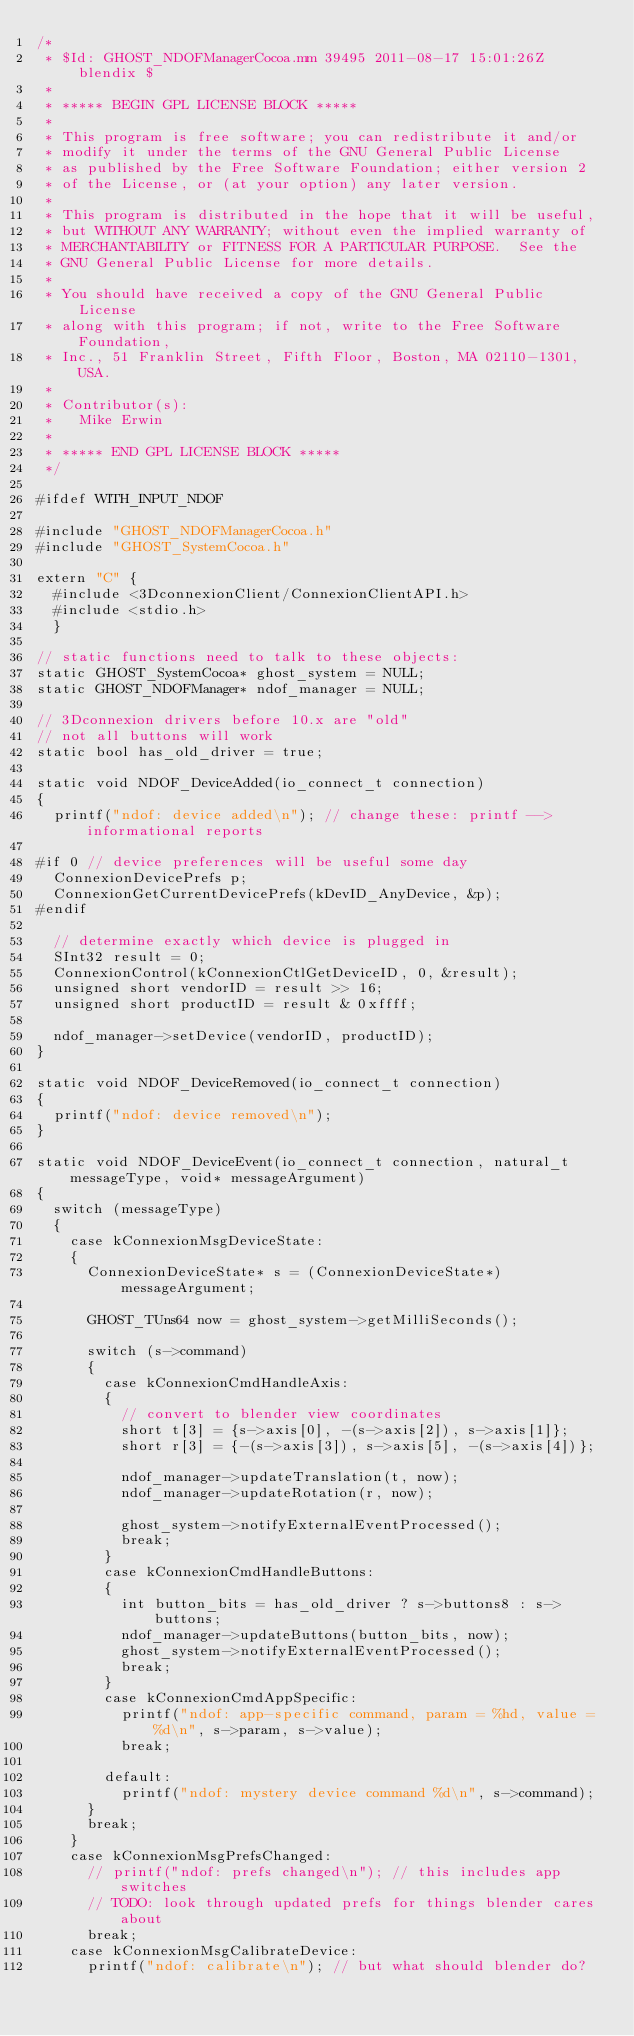<code> <loc_0><loc_0><loc_500><loc_500><_ObjectiveC_>/*
 * $Id: GHOST_NDOFManagerCocoa.mm 39495 2011-08-17 15:01:26Z blendix $
 *
 * ***** BEGIN GPL LICENSE BLOCK *****
 *
 * This program is free software; you can redistribute it and/or
 * modify it under the terms of the GNU General Public License
 * as published by the Free Software Foundation; either version 2
 * of the License, or (at your option) any later version. 
 *
 * This program is distributed in the hope that it will be useful,
 * but WITHOUT ANY WARRANTY; without even the implied warranty of
 * MERCHANTABILITY or FITNESS FOR A PARTICULAR PURPOSE.  See the
 * GNU General Public License for more details.
 *
 * You should have received a copy of the GNU General Public License
 * along with this program; if not, write to the Free Software Foundation,
 * Inc., 51 Franklin Street, Fifth Floor, Boston, MA 02110-1301, USA.
 *
 * Contributor(s):
 *   Mike Erwin
 *
 * ***** END GPL LICENSE BLOCK *****
 */

#ifdef WITH_INPUT_NDOF

#include "GHOST_NDOFManagerCocoa.h"
#include "GHOST_SystemCocoa.h"

extern "C" {
	#include <3DconnexionClient/ConnexionClientAPI.h>
	#include <stdio.h>
	}

// static functions need to talk to these objects:
static GHOST_SystemCocoa* ghost_system = NULL;
static GHOST_NDOFManager* ndof_manager = NULL;

// 3Dconnexion drivers before 10.x are "old"
// not all buttons will work
static bool has_old_driver = true;

static void NDOF_DeviceAdded(io_connect_t connection)
{
	printf("ndof: device added\n"); // change these: printf --> informational reports

#if 0 // device preferences will be useful some day
	ConnexionDevicePrefs p;
	ConnexionGetCurrentDevicePrefs(kDevID_AnyDevice, &p);
#endif

	// determine exactly which device is plugged in
	SInt32 result = 0;
	ConnexionControl(kConnexionCtlGetDeviceID, 0, &result);
	unsigned short vendorID = result >> 16;
	unsigned short productID = result & 0xffff;

	ndof_manager->setDevice(vendorID, productID);
}

static void NDOF_DeviceRemoved(io_connect_t connection)
{
	printf("ndof: device removed\n");
}

static void NDOF_DeviceEvent(io_connect_t connection, natural_t messageType, void* messageArgument)
{
	switch (messageType)
	{
		case kConnexionMsgDeviceState:
		{
			ConnexionDeviceState* s = (ConnexionDeviceState*)messageArgument;

			GHOST_TUns64 now = ghost_system->getMilliSeconds();

			switch (s->command)
			{
				case kConnexionCmdHandleAxis:
				{
					// convert to blender view coordinates
					short t[3] = {s->axis[0], -(s->axis[2]), s->axis[1]};
					short r[3] = {-(s->axis[3]), s->axis[5], -(s->axis[4])};

					ndof_manager->updateTranslation(t, now);
					ndof_manager->updateRotation(r, now);

					ghost_system->notifyExternalEventProcessed();
					break;
				}
				case kConnexionCmdHandleButtons:
				{
					int button_bits = has_old_driver ? s->buttons8 : s->buttons;
					ndof_manager->updateButtons(button_bits, now);
					ghost_system->notifyExternalEventProcessed();
					break;
				}
				case kConnexionCmdAppSpecific:
					printf("ndof: app-specific command, param = %hd, value = %d\n", s->param, s->value);
					break;

				default:
					printf("ndof: mystery device command %d\n", s->command);
			}
			break;
		}
		case kConnexionMsgPrefsChanged:
			// printf("ndof: prefs changed\n"); // this includes app switches
			// TODO: look through updated prefs for things blender cares about
			break;
		case kConnexionMsgCalibrateDevice:
			printf("ndof: calibrate\n"); // but what should blender do?</code> 